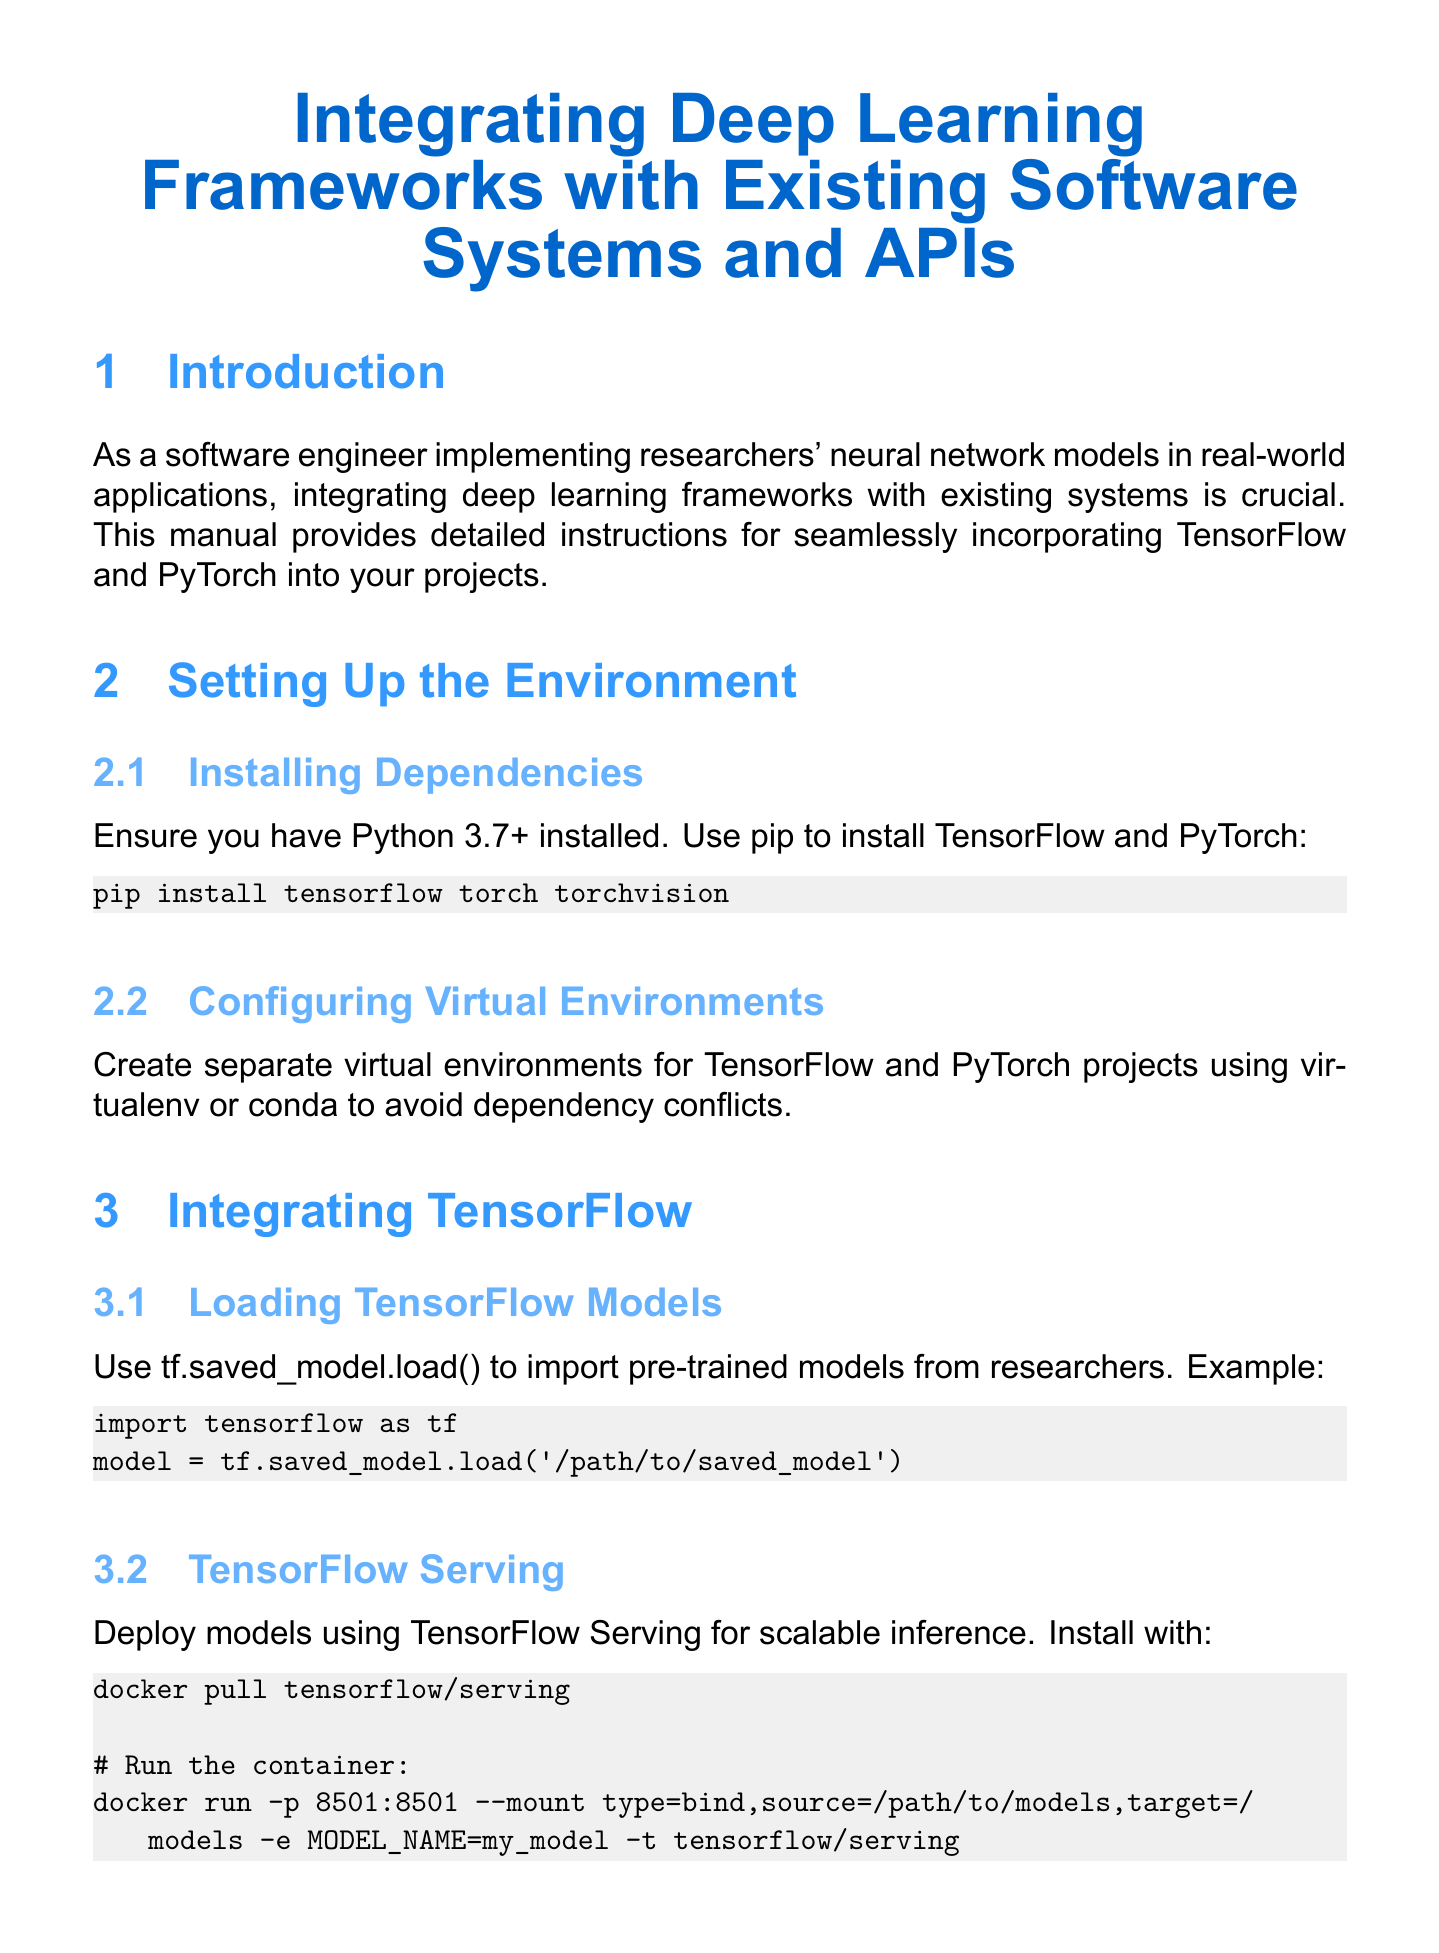What are the deep learning frameworks discussed? The manual focuses on integrating TensorFlow and PyTorch with existing systems.
Answer: TensorFlow and PyTorch What is the Python version required? The document specifies that Python 3.7 or higher is necessary for setting up the environment.
Answer: 3.7+ What command is used to install TensorFlow and PyTorch? The installation command mentioned in the manual is given in a code snippet for clarity.
Answer: pip install tensorflow torch torchvision What is the purpose of TensorRT? The manual provides information about TensorRT concerning optimization for TensorFlow models.
Answer: Optimize TensorFlow models What method is used to load pre-trained TensorFlow models? The document describes a specific method for importing TensorFlow models from saved files.
Answer: tf.saved_model.load() What format does PyTorch use for exporting models for cross-framework compatibility? The document mentions a conversion format that ensures compatibility between different deep learning frameworks.
Answer: ONNX What API framework is suggested for creating a model inference service? The manual suggests a particular web framework to build an API for serving predictions from the model.
Answer: Flask What happens when GPU memory exceeds limits during model inference? The document outlines a procedure for handling resource constraints during prediction.
Answer: Falls back to CPU How can you visualize model performance? The manual discusses a specific tool for visualizing training and performance metrics of models.
Answer: TensorBoard 